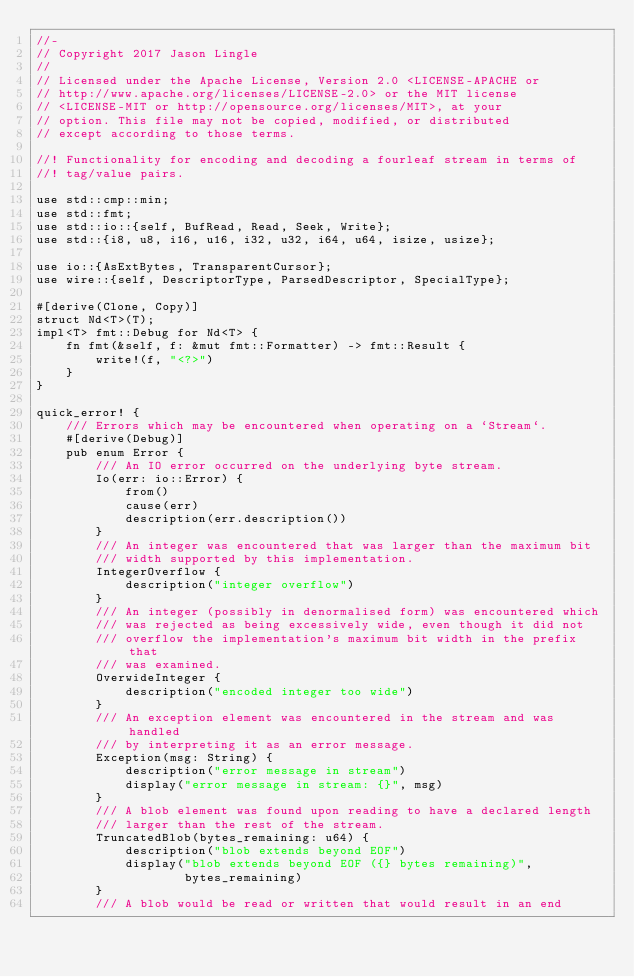<code> <loc_0><loc_0><loc_500><loc_500><_Rust_>//-
// Copyright 2017 Jason Lingle
//
// Licensed under the Apache License, Version 2.0 <LICENSE-APACHE or
// http://www.apache.org/licenses/LICENSE-2.0> or the MIT license
// <LICENSE-MIT or http://opensource.org/licenses/MIT>, at your
// option. This file may not be copied, modified, or distributed
// except according to those terms.

//! Functionality for encoding and decoding a fourleaf stream in terms of
//! tag/value pairs.

use std::cmp::min;
use std::fmt;
use std::io::{self, BufRead, Read, Seek, Write};
use std::{i8, u8, i16, u16, i32, u32, i64, u64, isize, usize};

use io::{AsExtBytes, TransparentCursor};
use wire::{self, DescriptorType, ParsedDescriptor, SpecialType};

#[derive(Clone, Copy)]
struct Nd<T>(T);
impl<T> fmt::Debug for Nd<T> {
    fn fmt(&self, f: &mut fmt::Formatter) -> fmt::Result {
        write!(f, "<?>")
    }
}

quick_error! {
    /// Errors which may be encountered when operating on a `Stream`.
    #[derive(Debug)]
    pub enum Error {
        /// An IO error occurred on the underlying byte stream.
        Io(err: io::Error) {
            from()
            cause(err)
            description(err.description())
        }
        /// An integer was encountered that was larger than the maximum bit
        /// width supported by this implementation.
        IntegerOverflow {
            description("integer overflow")
        }
        /// An integer (possibly in denormalised form) was encountered which
        /// was rejected as being excessively wide, even though it did not
        /// overflow the implementation's maximum bit width in the prefix that
        /// was examined.
        OverwideInteger {
            description("encoded integer too wide")
        }
        /// An exception element was encountered in the stream and was handled
        /// by interpreting it as an error message.
        Exception(msg: String) {
            description("error message in stream")
            display("error message in stream: {}", msg)
        }
        /// A blob element was found upon reading to have a declared length
        /// larger than the rest of the stream.
        TruncatedBlob(bytes_remaining: u64) {
            description("blob extends beyond EOF")
            display("blob extends beyond EOF ({} bytes remaining)",
                    bytes_remaining)
        }
        /// A blob would be read or written that would result in an end</code> 